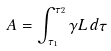Convert formula to latex. <formula><loc_0><loc_0><loc_500><loc_500>A = \int _ { \tau _ { 1 } } ^ { \tau _ { 2 } } \gamma L \, d \tau</formula> 